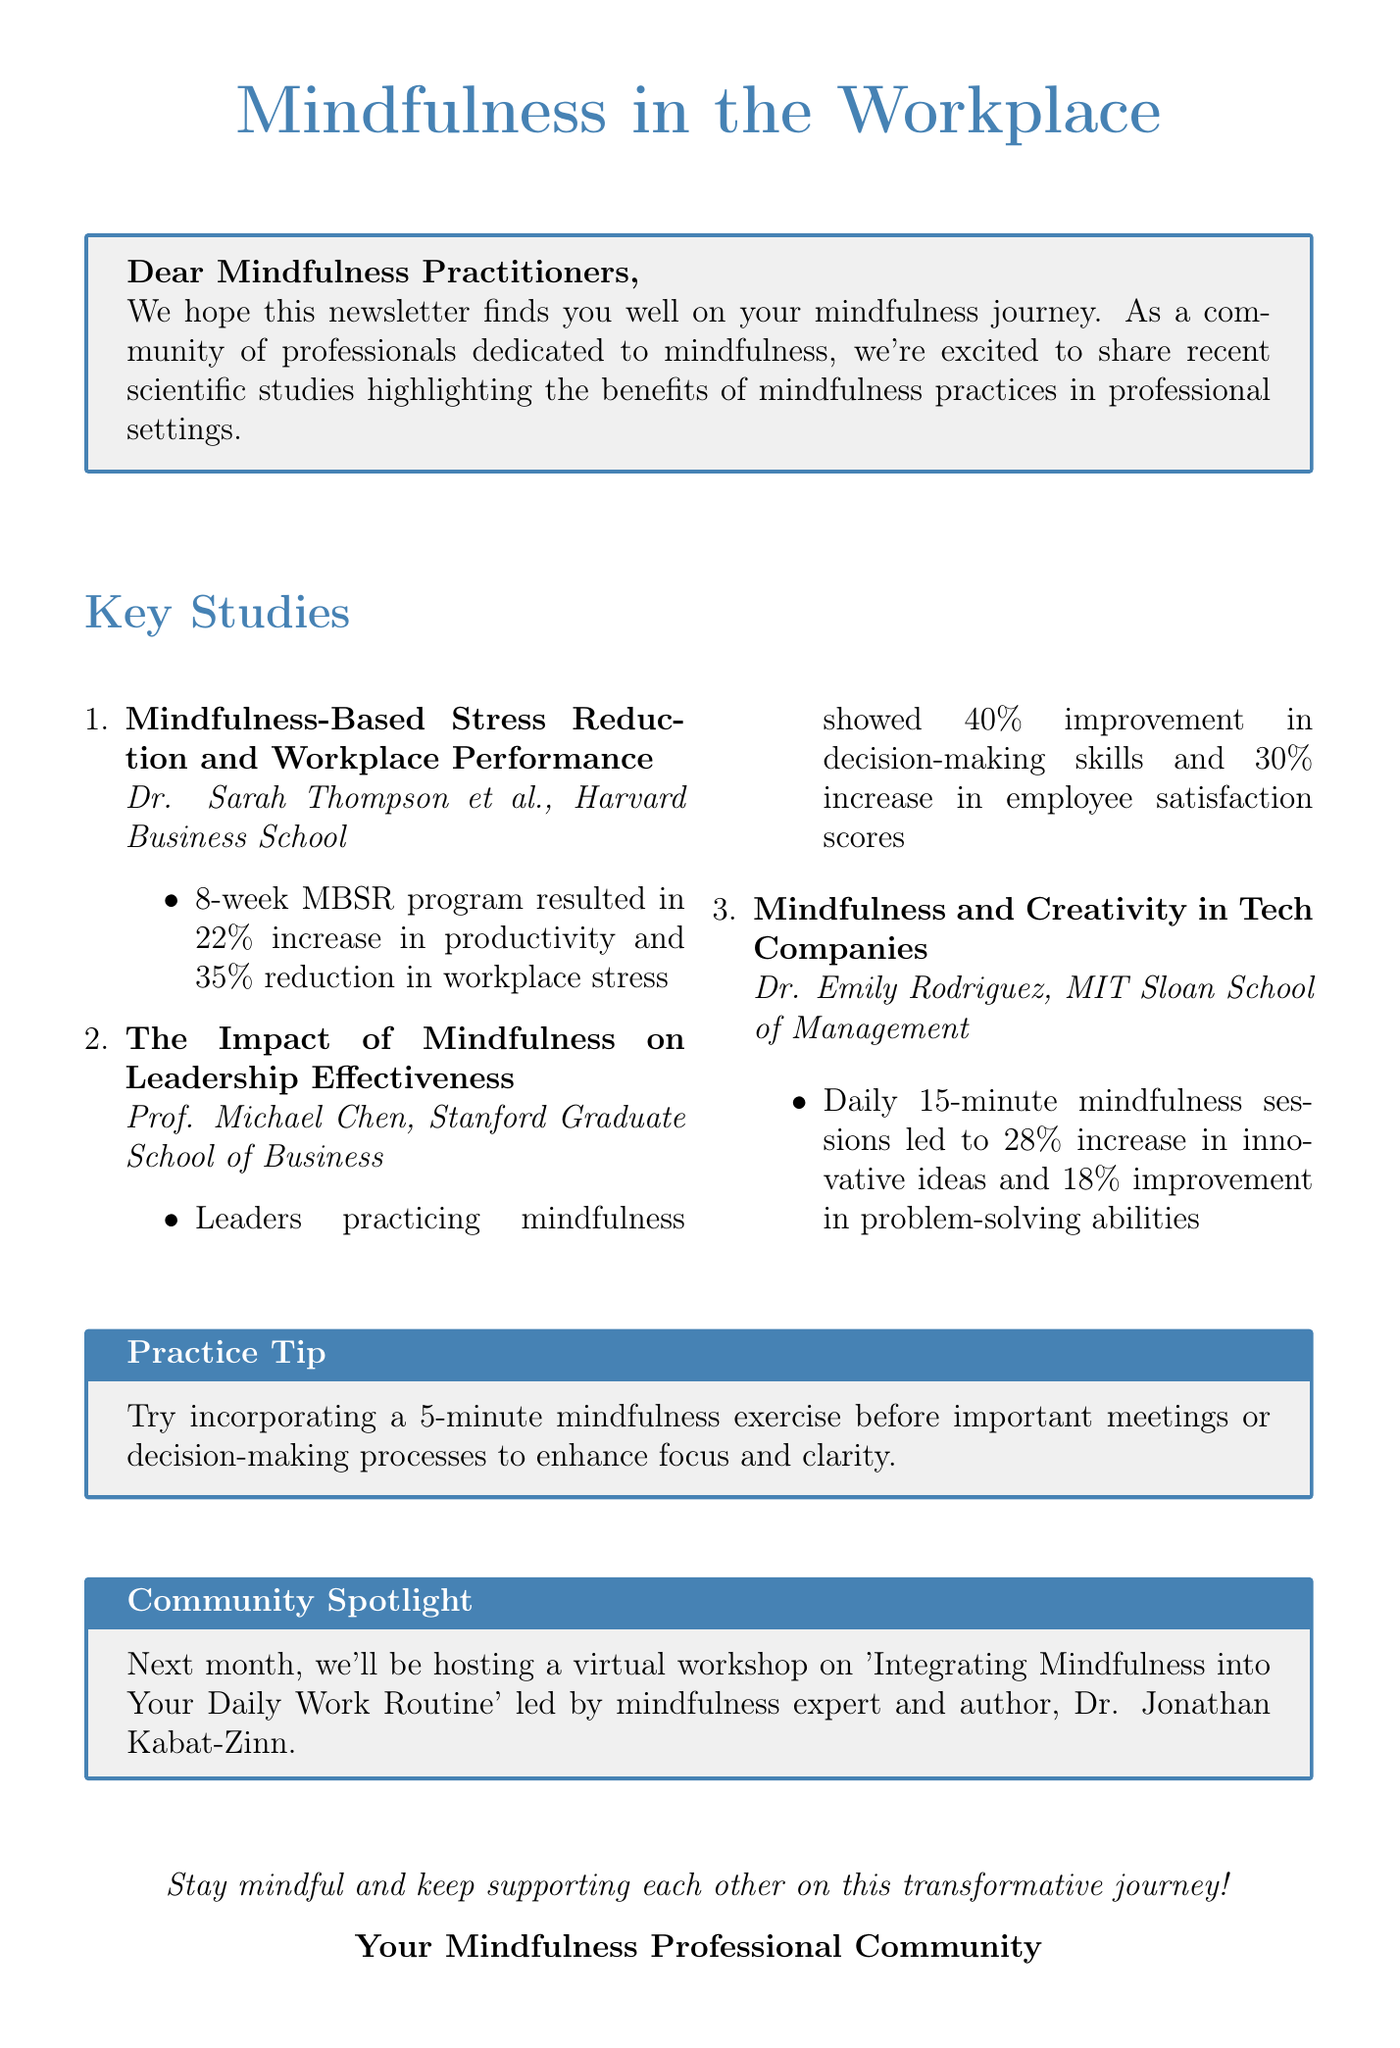What is the subject of the newsletter? The subject is clearly stated at the beginning of the document, which is to inform about recent research on mindfulness in the workplace.
Answer: Latest Research: Mindfulness in the Workplace - Unveiling the Professional Benefits Who conducted the study on Mindfulness-Based Stress Reduction? The researchers of the study are mentioned directly following the title of the study.
Answer: Dr. Sarah Thompson et al., Harvard Business School What percentage increase in productivity was reported from the MBSR program? The findings section for the MBSR program specifies the increase in productivity.
Answer: 22% What was the primary focus of Prof. Michael Chen's study? The title of the study by Prof. Michael Chen indicates it is focused on leadership effectiveness.
Answer: Leadership Effectiveness What is the suggested practice tip mentioned in the newsletter? A specific mindfulness exercise is recommended for enhancing focus.
Answer: 5-minute mindfulness exercise before important meetings How much improvement in employee satisfaction scores is associated with mindful leaders? The findings of Prof. Michael Chen's study report a specific increase in employee satisfaction.
Answer: 30% Which university is associated with Dr. Emily Rodriguez? The study conducted by Dr. Emily Rodriguez mentions her affiliation with a specific institution.
Answer: MIT Sloan School of Management What future activity is highlighted in the Community Spotlight? The Community Spotlight mentions an upcoming workshop led by a mindfulness expert.
Answer: Virtual workshop on 'Integrating Mindfulness into Your Daily Work Routine' 